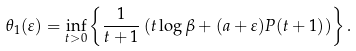Convert formula to latex. <formula><loc_0><loc_0><loc_500><loc_500>\theta _ { 1 } ( \varepsilon ) = \inf _ { t > 0 } \left \{ \frac { 1 } { t + 1 } \left ( t \log \beta + ( a + \varepsilon ) P ( t + 1 ) \right ) \right \} .</formula> 